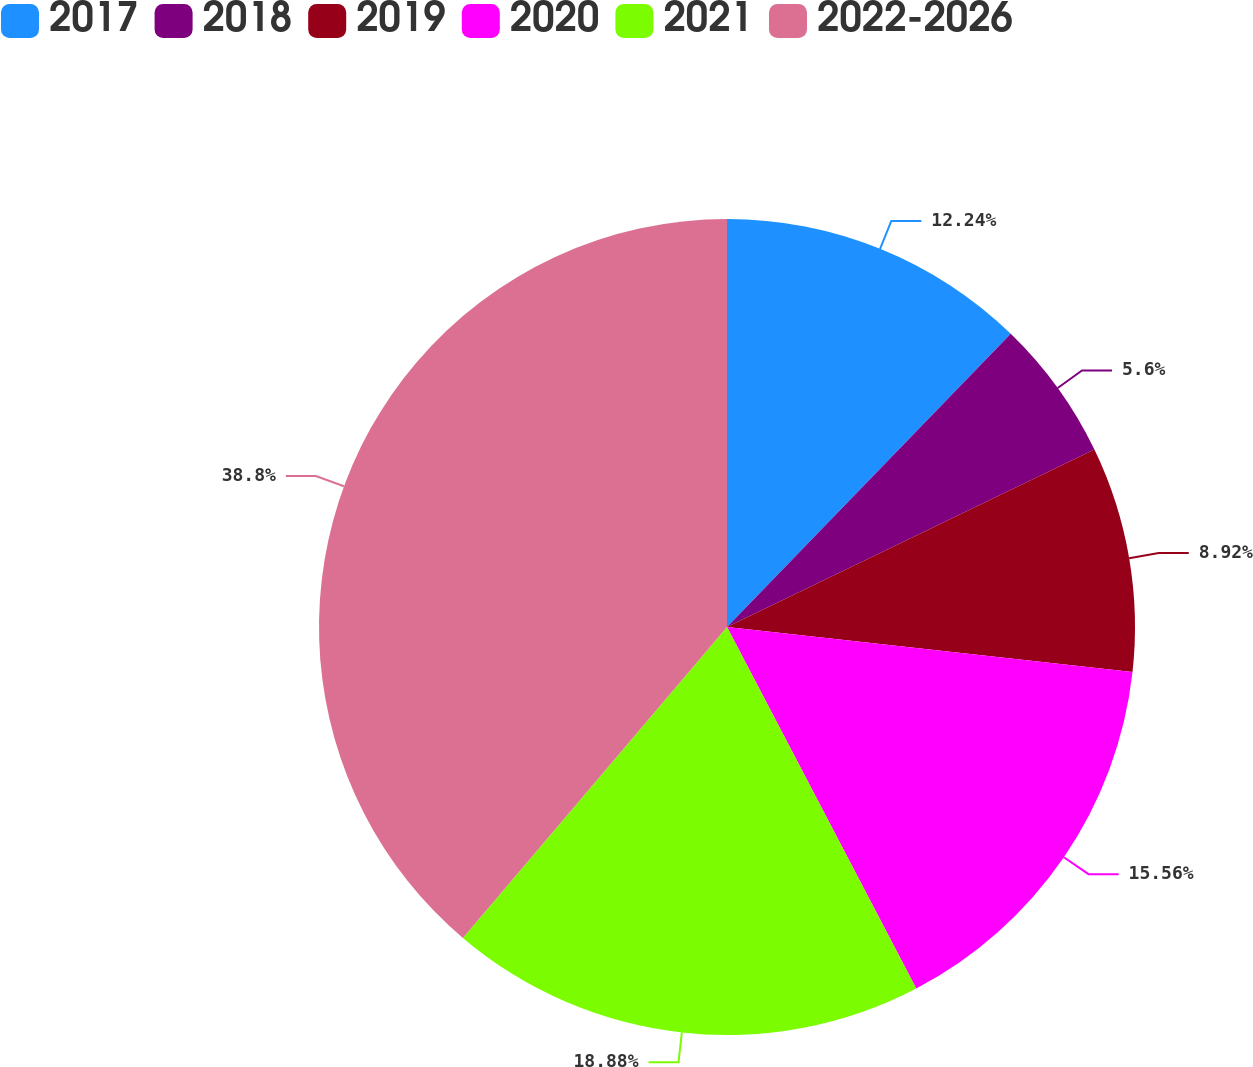Convert chart to OTSL. <chart><loc_0><loc_0><loc_500><loc_500><pie_chart><fcel>2017<fcel>2018<fcel>2019<fcel>2020<fcel>2021<fcel>2022-2026<nl><fcel>12.24%<fcel>5.6%<fcel>8.92%<fcel>15.56%<fcel>18.88%<fcel>38.79%<nl></chart> 